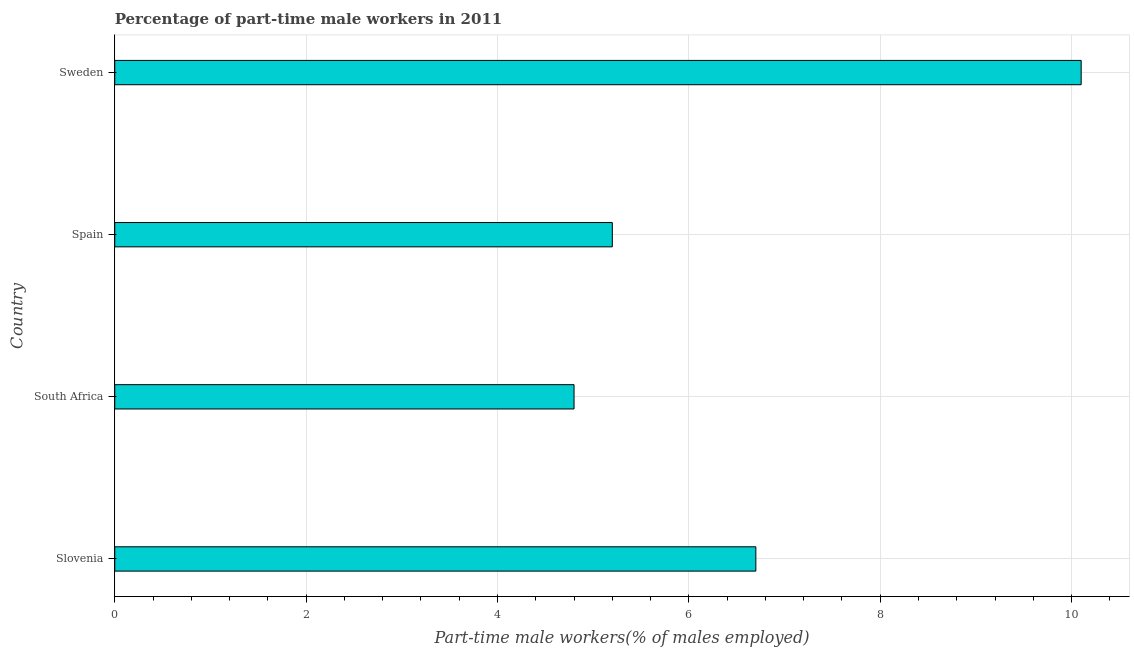What is the title of the graph?
Offer a terse response. Percentage of part-time male workers in 2011. What is the label or title of the X-axis?
Provide a succinct answer. Part-time male workers(% of males employed). What is the percentage of part-time male workers in South Africa?
Make the answer very short. 4.8. Across all countries, what is the maximum percentage of part-time male workers?
Provide a short and direct response. 10.1. Across all countries, what is the minimum percentage of part-time male workers?
Keep it short and to the point. 4.8. In which country was the percentage of part-time male workers maximum?
Your response must be concise. Sweden. In which country was the percentage of part-time male workers minimum?
Provide a succinct answer. South Africa. What is the sum of the percentage of part-time male workers?
Offer a terse response. 26.8. What is the average percentage of part-time male workers per country?
Offer a very short reply. 6.7. What is the median percentage of part-time male workers?
Your answer should be very brief. 5.95. What is the ratio of the percentage of part-time male workers in South Africa to that in Sweden?
Offer a terse response. 0.47. Is the percentage of part-time male workers in Slovenia less than that in South Africa?
Provide a succinct answer. No. Is the difference between the percentage of part-time male workers in Slovenia and Spain greater than the difference between any two countries?
Keep it short and to the point. No. Is the sum of the percentage of part-time male workers in Slovenia and Spain greater than the maximum percentage of part-time male workers across all countries?
Offer a very short reply. Yes. How many bars are there?
Provide a short and direct response. 4. How many countries are there in the graph?
Ensure brevity in your answer.  4. What is the difference between two consecutive major ticks on the X-axis?
Keep it short and to the point. 2. Are the values on the major ticks of X-axis written in scientific E-notation?
Offer a very short reply. No. What is the Part-time male workers(% of males employed) of Slovenia?
Ensure brevity in your answer.  6.7. What is the Part-time male workers(% of males employed) in South Africa?
Provide a short and direct response. 4.8. What is the Part-time male workers(% of males employed) of Spain?
Provide a short and direct response. 5.2. What is the Part-time male workers(% of males employed) in Sweden?
Provide a short and direct response. 10.1. What is the difference between the Part-time male workers(% of males employed) in Slovenia and South Africa?
Provide a short and direct response. 1.9. What is the difference between the Part-time male workers(% of males employed) in Slovenia and Sweden?
Your answer should be compact. -3.4. What is the difference between the Part-time male workers(% of males employed) in South Africa and Sweden?
Your answer should be compact. -5.3. What is the ratio of the Part-time male workers(% of males employed) in Slovenia to that in South Africa?
Your response must be concise. 1.4. What is the ratio of the Part-time male workers(% of males employed) in Slovenia to that in Spain?
Provide a short and direct response. 1.29. What is the ratio of the Part-time male workers(% of males employed) in Slovenia to that in Sweden?
Your answer should be compact. 0.66. What is the ratio of the Part-time male workers(% of males employed) in South Africa to that in Spain?
Ensure brevity in your answer.  0.92. What is the ratio of the Part-time male workers(% of males employed) in South Africa to that in Sweden?
Your response must be concise. 0.47. What is the ratio of the Part-time male workers(% of males employed) in Spain to that in Sweden?
Your answer should be very brief. 0.52. 